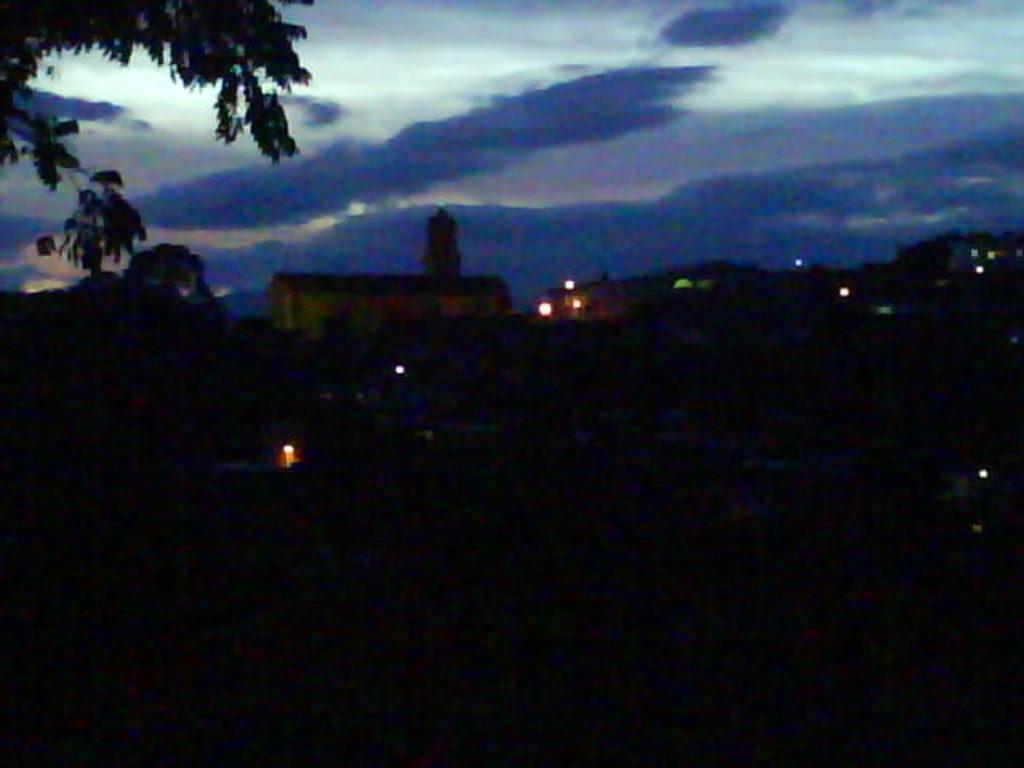How would you summarize this image in a sentence or two? This picture is taken in the nighttime. In this image we can see that there are lights in some parts. At the top there is the sky. On the left side top there are leaves. 